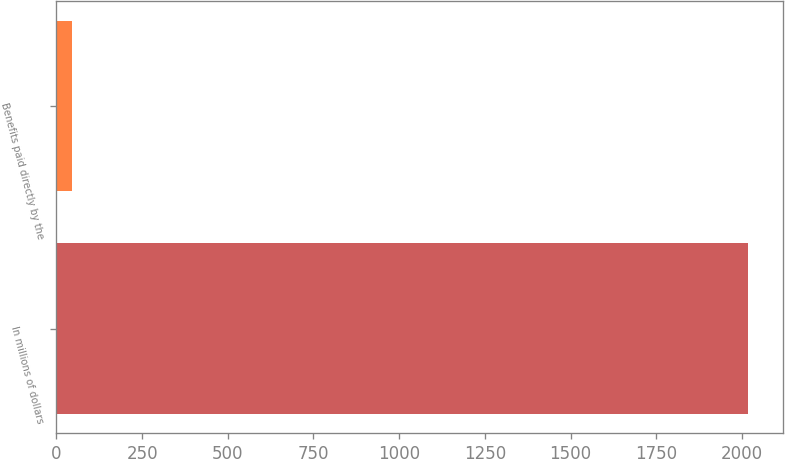<chart> <loc_0><loc_0><loc_500><loc_500><bar_chart><fcel>In millions of dollars<fcel>Benefits paid directly by the<nl><fcel>2019<fcel>47<nl></chart> 